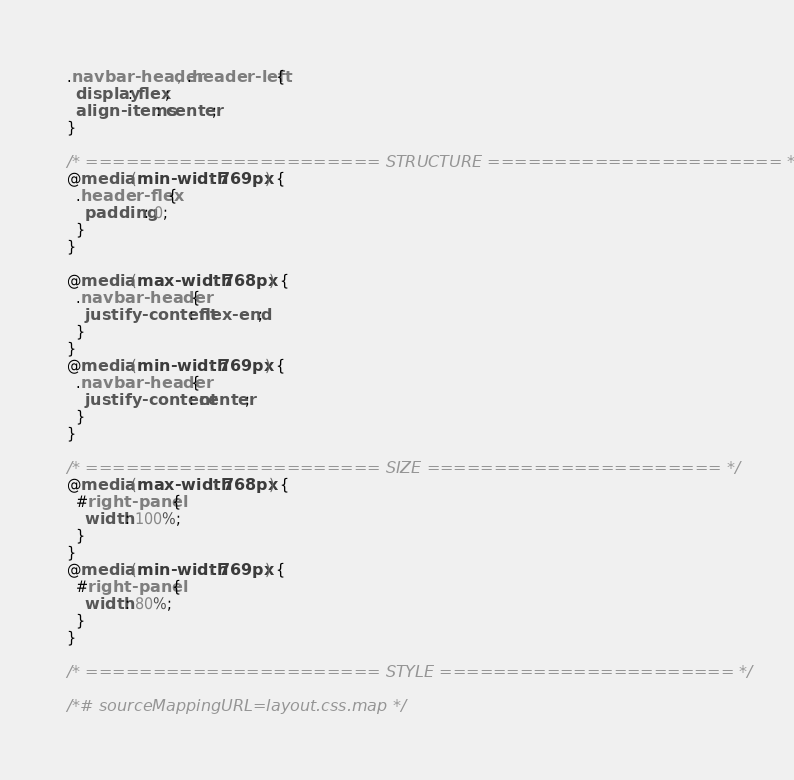<code> <loc_0><loc_0><loc_500><loc_500><_CSS_>.navbar-header, .header-left {
  display: flex;
  align-items: center;
}

/* ====================== STRUCTURE ====================== */
@media (min-width: 769px) {
  .header-flex {
    padding: 0;
  }
}

@media (max-width: 768px) {
  .navbar-header {
    justify-content: flex-end;
  }
}
@media (min-width: 769px) {
  .navbar-header {
    justify-content: center;
  }
}

/* ====================== SIZE ====================== */
@media (max-width: 768px) {
  #right-panel {
    width: 100%;
  }
}
@media (min-width: 769px) {
  #right-panel {
    width: 80%;
  }
}

/* ====================== STYLE ====================== */

/*# sourceMappingURL=layout.css.map */
</code> 